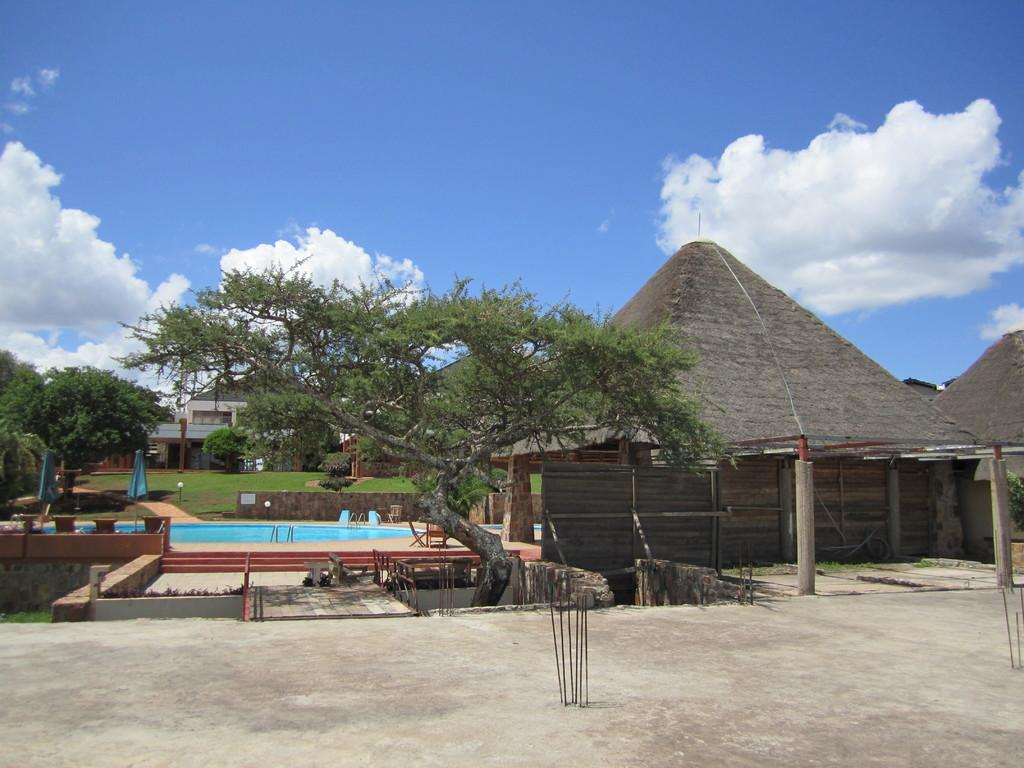What type of structure is visible in the image? There is a building in the image. What other natural elements can be seen in the image? There are trees and a pool visible in the image. What type of dwellings are present in the image? There are huts in the image. What colors can be seen in the sky in the image? The sky is white and blue in color. Where are the scissors located in the image? There are no scissors present in the image. What type of lip can be seen on the trees in the image? There are no lips present in the image, as it features trees and other natural elements. Are there any dinosaurs visible in the image? There are no dinosaurs present in the image; it features a building, trees, a pool, huts, and a sky with white and blue colors. 